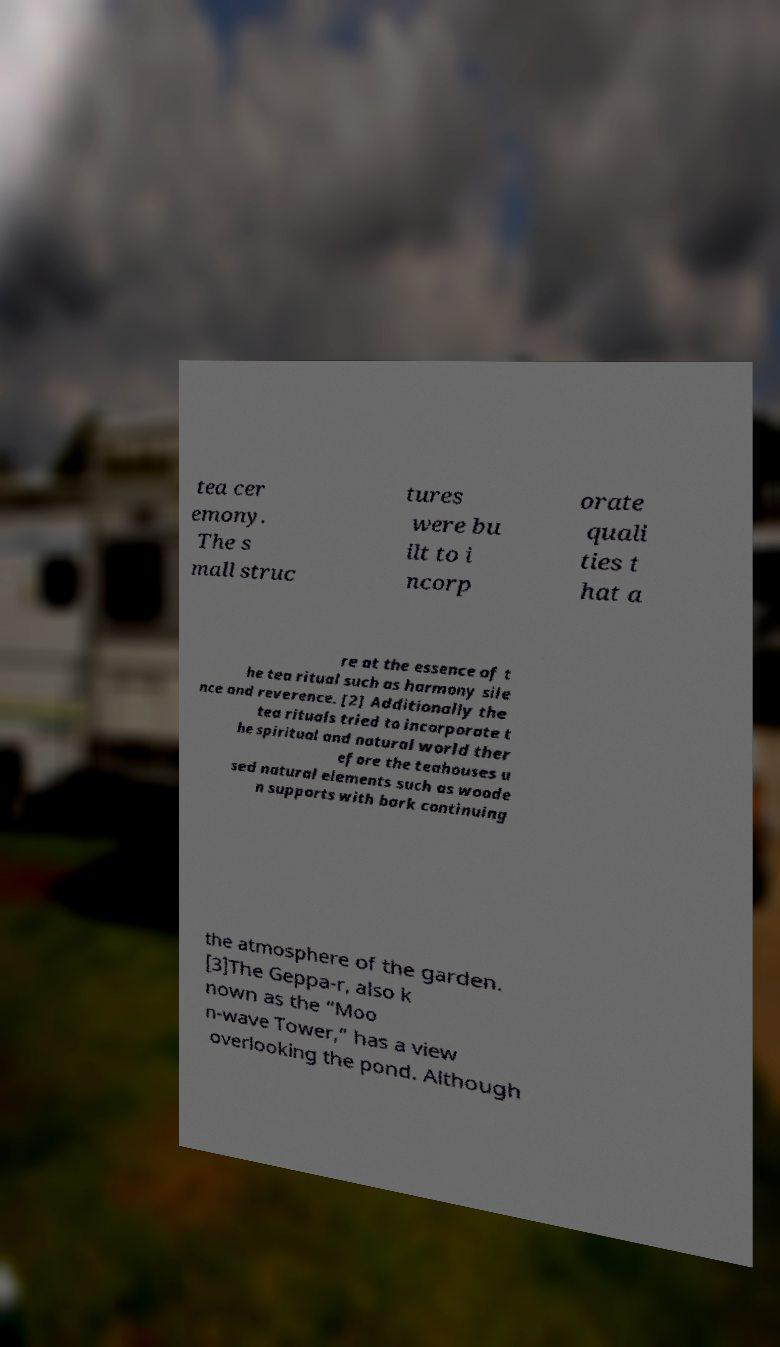There's text embedded in this image that I need extracted. Can you transcribe it verbatim? tea cer emony. The s mall struc tures were bu ilt to i ncorp orate quali ties t hat a re at the essence of t he tea ritual such as harmony sile nce and reverence. [2] Additionally the tea rituals tried to incorporate t he spiritual and natural world ther efore the teahouses u sed natural elements such as woode n supports with bark continuing the atmosphere of the garden. [3]The Geppa-r, also k nown as the “Moo n-wave Tower,” has a view overlooking the pond. Although 